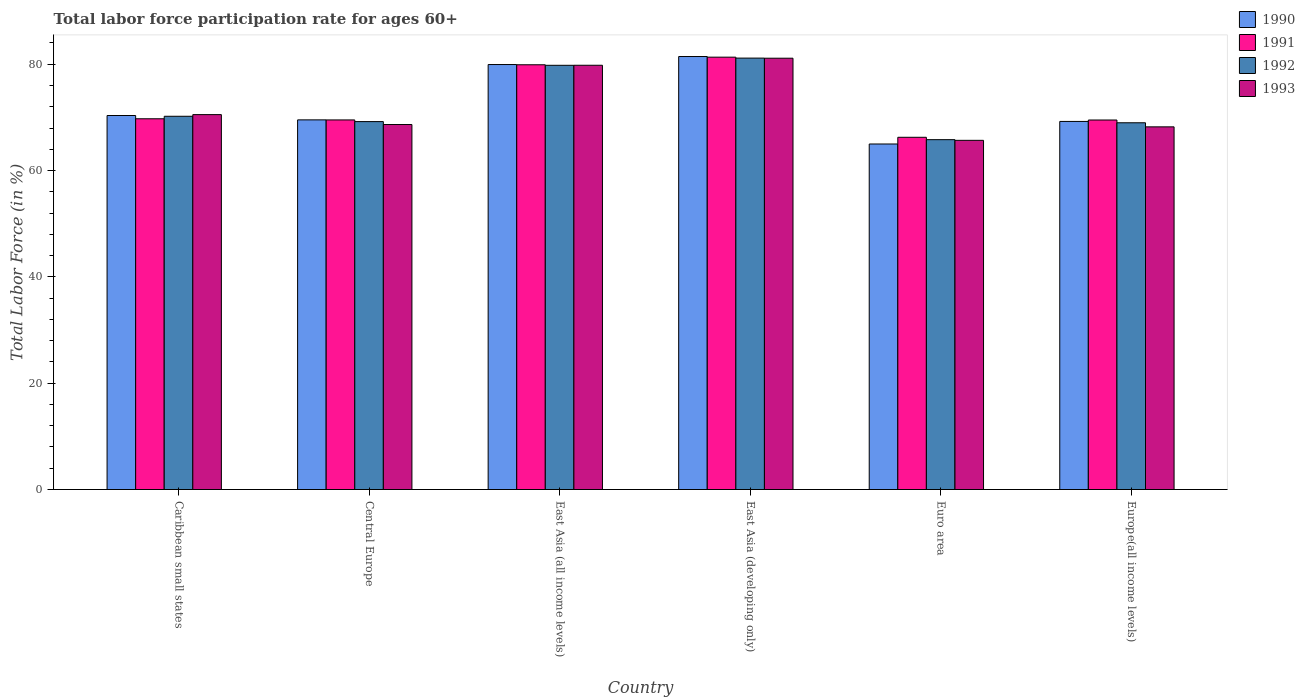Are the number of bars on each tick of the X-axis equal?
Offer a terse response. Yes. How many bars are there on the 6th tick from the left?
Provide a succinct answer. 4. How many bars are there on the 6th tick from the right?
Your response must be concise. 4. What is the label of the 1st group of bars from the left?
Offer a very short reply. Caribbean small states. In how many cases, is the number of bars for a given country not equal to the number of legend labels?
Your response must be concise. 0. What is the labor force participation rate in 1991 in East Asia (developing only)?
Give a very brief answer. 81.33. Across all countries, what is the maximum labor force participation rate in 1993?
Make the answer very short. 81.14. Across all countries, what is the minimum labor force participation rate in 1993?
Your response must be concise. 65.69. In which country was the labor force participation rate in 1990 maximum?
Your response must be concise. East Asia (developing only). In which country was the labor force participation rate in 1993 minimum?
Your answer should be compact. Euro area. What is the total labor force participation rate in 1990 in the graph?
Offer a very short reply. 435.54. What is the difference between the labor force participation rate in 1991 in East Asia (all income levels) and that in East Asia (developing only)?
Offer a very short reply. -1.43. What is the difference between the labor force participation rate in 1992 in Euro area and the labor force participation rate in 1990 in East Asia (developing only)?
Your answer should be compact. -15.64. What is the average labor force participation rate in 1991 per country?
Provide a short and direct response. 72.71. What is the difference between the labor force participation rate of/in 1990 and labor force participation rate of/in 1993 in East Asia (all income levels)?
Your answer should be compact. 0.14. In how many countries, is the labor force participation rate in 1993 greater than 72 %?
Your response must be concise. 2. What is the ratio of the labor force participation rate in 1992 in Caribbean small states to that in East Asia (developing only)?
Ensure brevity in your answer.  0.87. What is the difference between the highest and the second highest labor force participation rate in 1991?
Ensure brevity in your answer.  11.59. What is the difference between the highest and the lowest labor force participation rate in 1993?
Make the answer very short. 15.45. In how many countries, is the labor force participation rate in 1990 greater than the average labor force participation rate in 1990 taken over all countries?
Keep it short and to the point. 2. What does the 3rd bar from the right in Central Europe represents?
Give a very brief answer. 1991. Is it the case that in every country, the sum of the labor force participation rate in 1992 and labor force participation rate in 1990 is greater than the labor force participation rate in 1991?
Offer a very short reply. Yes. What is the difference between two consecutive major ticks on the Y-axis?
Offer a terse response. 20. Does the graph contain any zero values?
Provide a succinct answer. No. Does the graph contain grids?
Your answer should be very brief. No. How are the legend labels stacked?
Ensure brevity in your answer.  Vertical. What is the title of the graph?
Your response must be concise. Total labor force participation rate for ages 60+. Does "1972" appear as one of the legend labels in the graph?
Your answer should be compact. No. What is the label or title of the X-axis?
Provide a succinct answer. Country. What is the label or title of the Y-axis?
Your response must be concise. Total Labor Force (in %). What is the Total Labor Force (in %) in 1990 in Caribbean small states?
Your answer should be very brief. 70.36. What is the Total Labor Force (in %) in 1991 in Caribbean small states?
Provide a short and direct response. 69.74. What is the Total Labor Force (in %) in 1992 in Caribbean small states?
Offer a very short reply. 70.21. What is the Total Labor Force (in %) in 1993 in Caribbean small states?
Offer a terse response. 70.53. What is the Total Labor Force (in %) in 1990 in Central Europe?
Offer a terse response. 69.54. What is the Total Labor Force (in %) in 1991 in Central Europe?
Your response must be concise. 69.52. What is the Total Labor Force (in %) in 1992 in Central Europe?
Your answer should be compact. 69.21. What is the Total Labor Force (in %) of 1993 in Central Europe?
Give a very brief answer. 68.66. What is the Total Labor Force (in %) of 1990 in East Asia (all income levels)?
Provide a succinct answer. 79.95. What is the Total Labor Force (in %) of 1991 in East Asia (all income levels)?
Your answer should be compact. 79.9. What is the Total Labor Force (in %) of 1992 in East Asia (all income levels)?
Keep it short and to the point. 79.8. What is the Total Labor Force (in %) of 1993 in East Asia (all income levels)?
Your answer should be compact. 79.81. What is the Total Labor Force (in %) of 1990 in East Asia (developing only)?
Provide a succinct answer. 81.45. What is the Total Labor Force (in %) of 1991 in East Asia (developing only)?
Your answer should be compact. 81.33. What is the Total Labor Force (in %) of 1992 in East Asia (developing only)?
Make the answer very short. 81.16. What is the Total Labor Force (in %) in 1993 in East Asia (developing only)?
Keep it short and to the point. 81.14. What is the Total Labor Force (in %) in 1990 in Euro area?
Offer a terse response. 65. What is the Total Labor Force (in %) of 1991 in Euro area?
Your response must be concise. 66.26. What is the Total Labor Force (in %) in 1992 in Euro area?
Give a very brief answer. 65.81. What is the Total Labor Force (in %) in 1993 in Euro area?
Your answer should be compact. 65.69. What is the Total Labor Force (in %) of 1990 in Europe(all income levels)?
Keep it short and to the point. 69.24. What is the Total Labor Force (in %) of 1991 in Europe(all income levels)?
Give a very brief answer. 69.51. What is the Total Labor Force (in %) of 1992 in Europe(all income levels)?
Offer a terse response. 68.99. What is the Total Labor Force (in %) in 1993 in Europe(all income levels)?
Your answer should be compact. 68.22. Across all countries, what is the maximum Total Labor Force (in %) in 1990?
Keep it short and to the point. 81.45. Across all countries, what is the maximum Total Labor Force (in %) in 1991?
Give a very brief answer. 81.33. Across all countries, what is the maximum Total Labor Force (in %) in 1992?
Provide a succinct answer. 81.16. Across all countries, what is the maximum Total Labor Force (in %) of 1993?
Your answer should be compact. 81.14. Across all countries, what is the minimum Total Labor Force (in %) of 1990?
Provide a short and direct response. 65. Across all countries, what is the minimum Total Labor Force (in %) in 1991?
Offer a very short reply. 66.26. Across all countries, what is the minimum Total Labor Force (in %) of 1992?
Your answer should be compact. 65.81. Across all countries, what is the minimum Total Labor Force (in %) of 1993?
Provide a succinct answer. 65.69. What is the total Total Labor Force (in %) of 1990 in the graph?
Give a very brief answer. 435.54. What is the total Total Labor Force (in %) of 1991 in the graph?
Provide a short and direct response. 436.27. What is the total Total Labor Force (in %) of 1992 in the graph?
Provide a short and direct response. 435.19. What is the total Total Labor Force (in %) in 1993 in the graph?
Keep it short and to the point. 434.05. What is the difference between the Total Labor Force (in %) in 1990 in Caribbean small states and that in Central Europe?
Your answer should be compact. 0.82. What is the difference between the Total Labor Force (in %) in 1991 in Caribbean small states and that in Central Europe?
Your answer should be very brief. 0.22. What is the difference between the Total Labor Force (in %) of 1992 in Caribbean small states and that in Central Europe?
Provide a short and direct response. 1. What is the difference between the Total Labor Force (in %) of 1993 in Caribbean small states and that in Central Europe?
Provide a short and direct response. 1.86. What is the difference between the Total Labor Force (in %) of 1990 in Caribbean small states and that in East Asia (all income levels)?
Keep it short and to the point. -9.59. What is the difference between the Total Labor Force (in %) of 1991 in Caribbean small states and that in East Asia (all income levels)?
Offer a very short reply. -10.16. What is the difference between the Total Labor Force (in %) of 1992 in Caribbean small states and that in East Asia (all income levels)?
Give a very brief answer. -9.59. What is the difference between the Total Labor Force (in %) in 1993 in Caribbean small states and that in East Asia (all income levels)?
Make the answer very short. -9.28. What is the difference between the Total Labor Force (in %) of 1990 in Caribbean small states and that in East Asia (developing only)?
Your answer should be compact. -11.1. What is the difference between the Total Labor Force (in %) of 1991 in Caribbean small states and that in East Asia (developing only)?
Ensure brevity in your answer.  -11.59. What is the difference between the Total Labor Force (in %) in 1992 in Caribbean small states and that in East Asia (developing only)?
Provide a short and direct response. -10.94. What is the difference between the Total Labor Force (in %) in 1993 in Caribbean small states and that in East Asia (developing only)?
Keep it short and to the point. -10.61. What is the difference between the Total Labor Force (in %) of 1990 in Caribbean small states and that in Euro area?
Keep it short and to the point. 5.36. What is the difference between the Total Labor Force (in %) in 1991 in Caribbean small states and that in Euro area?
Provide a succinct answer. 3.48. What is the difference between the Total Labor Force (in %) of 1992 in Caribbean small states and that in Euro area?
Your answer should be very brief. 4.4. What is the difference between the Total Labor Force (in %) in 1993 in Caribbean small states and that in Euro area?
Make the answer very short. 4.84. What is the difference between the Total Labor Force (in %) in 1990 in Caribbean small states and that in Europe(all income levels)?
Ensure brevity in your answer.  1.11. What is the difference between the Total Labor Force (in %) in 1991 in Caribbean small states and that in Europe(all income levels)?
Offer a very short reply. 0.23. What is the difference between the Total Labor Force (in %) in 1992 in Caribbean small states and that in Europe(all income levels)?
Offer a very short reply. 1.22. What is the difference between the Total Labor Force (in %) of 1993 in Caribbean small states and that in Europe(all income levels)?
Offer a very short reply. 2.3. What is the difference between the Total Labor Force (in %) in 1990 in Central Europe and that in East Asia (all income levels)?
Ensure brevity in your answer.  -10.41. What is the difference between the Total Labor Force (in %) in 1991 in Central Europe and that in East Asia (all income levels)?
Make the answer very short. -10.38. What is the difference between the Total Labor Force (in %) of 1992 in Central Europe and that in East Asia (all income levels)?
Make the answer very short. -10.59. What is the difference between the Total Labor Force (in %) of 1993 in Central Europe and that in East Asia (all income levels)?
Make the answer very short. -11.15. What is the difference between the Total Labor Force (in %) in 1990 in Central Europe and that in East Asia (developing only)?
Your answer should be very brief. -11.92. What is the difference between the Total Labor Force (in %) in 1991 in Central Europe and that in East Asia (developing only)?
Offer a terse response. -11.81. What is the difference between the Total Labor Force (in %) in 1992 in Central Europe and that in East Asia (developing only)?
Your response must be concise. -11.95. What is the difference between the Total Labor Force (in %) in 1993 in Central Europe and that in East Asia (developing only)?
Make the answer very short. -12.48. What is the difference between the Total Labor Force (in %) of 1990 in Central Europe and that in Euro area?
Provide a short and direct response. 4.54. What is the difference between the Total Labor Force (in %) of 1991 in Central Europe and that in Euro area?
Provide a succinct answer. 3.27. What is the difference between the Total Labor Force (in %) in 1992 in Central Europe and that in Euro area?
Ensure brevity in your answer.  3.4. What is the difference between the Total Labor Force (in %) of 1993 in Central Europe and that in Euro area?
Offer a terse response. 2.98. What is the difference between the Total Labor Force (in %) of 1990 in Central Europe and that in Europe(all income levels)?
Keep it short and to the point. 0.29. What is the difference between the Total Labor Force (in %) of 1991 in Central Europe and that in Europe(all income levels)?
Your answer should be very brief. 0.01. What is the difference between the Total Labor Force (in %) of 1992 in Central Europe and that in Europe(all income levels)?
Provide a short and direct response. 0.22. What is the difference between the Total Labor Force (in %) of 1993 in Central Europe and that in Europe(all income levels)?
Offer a terse response. 0.44. What is the difference between the Total Labor Force (in %) of 1990 in East Asia (all income levels) and that in East Asia (developing only)?
Give a very brief answer. -1.51. What is the difference between the Total Labor Force (in %) of 1991 in East Asia (all income levels) and that in East Asia (developing only)?
Your answer should be compact. -1.43. What is the difference between the Total Labor Force (in %) in 1992 in East Asia (all income levels) and that in East Asia (developing only)?
Offer a terse response. -1.36. What is the difference between the Total Labor Force (in %) in 1993 in East Asia (all income levels) and that in East Asia (developing only)?
Offer a terse response. -1.33. What is the difference between the Total Labor Force (in %) of 1990 in East Asia (all income levels) and that in Euro area?
Your answer should be compact. 14.95. What is the difference between the Total Labor Force (in %) in 1991 in East Asia (all income levels) and that in Euro area?
Offer a terse response. 13.64. What is the difference between the Total Labor Force (in %) in 1992 in East Asia (all income levels) and that in Euro area?
Give a very brief answer. 13.99. What is the difference between the Total Labor Force (in %) of 1993 in East Asia (all income levels) and that in Euro area?
Your response must be concise. 14.12. What is the difference between the Total Labor Force (in %) in 1990 in East Asia (all income levels) and that in Europe(all income levels)?
Provide a short and direct response. 10.7. What is the difference between the Total Labor Force (in %) in 1991 in East Asia (all income levels) and that in Europe(all income levels)?
Your response must be concise. 10.39. What is the difference between the Total Labor Force (in %) of 1992 in East Asia (all income levels) and that in Europe(all income levels)?
Your answer should be compact. 10.81. What is the difference between the Total Labor Force (in %) of 1993 in East Asia (all income levels) and that in Europe(all income levels)?
Provide a succinct answer. 11.59. What is the difference between the Total Labor Force (in %) of 1990 in East Asia (developing only) and that in Euro area?
Make the answer very short. 16.45. What is the difference between the Total Labor Force (in %) in 1991 in East Asia (developing only) and that in Euro area?
Ensure brevity in your answer.  15.07. What is the difference between the Total Labor Force (in %) of 1992 in East Asia (developing only) and that in Euro area?
Your answer should be very brief. 15.34. What is the difference between the Total Labor Force (in %) of 1993 in East Asia (developing only) and that in Euro area?
Ensure brevity in your answer.  15.45. What is the difference between the Total Labor Force (in %) of 1990 in East Asia (developing only) and that in Europe(all income levels)?
Give a very brief answer. 12.21. What is the difference between the Total Labor Force (in %) in 1991 in East Asia (developing only) and that in Europe(all income levels)?
Provide a succinct answer. 11.82. What is the difference between the Total Labor Force (in %) in 1992 in East Asia (developing only) and that in Europe(all income levels)?
Keep it short and to the point. 12.17. What is the difference between the Total Labor Force (in %) in 1993 in East Asia (developing only) and that in Europe(all income levels)?
Offer a terse response. 12.91. What is the difference between the Total Labor Force (in %) in 1990 in Euro area and that in Europe(all income levels)?
Give a very brief answer. -4.24. What is the difference between the Total Labor Force (in %) of 1991 in Euro area and that in Europe(all income levels)?
Offer a terse response. -3.25. What is the difference between the Total Labor Force (in %) of 1992 in Euro area and that in Europe(all income levels)?
Your answer should be very brief. -3.18. What is the difference between the Total Labor Force (in %) of 1993 in Euro area and that in Europe(all income levels)?
Provide a succinct answer. -2.54. What is the difference between the Total Labor Force (in %) in 1990 in Caribbean small states and the Total Labor Force (in %) in 1991 in Central Europe?
Make the answer very short. 0.83. What is the difference between the Total Labor Force (in %) in 1990 in Caribbean small states and the Total Labor Force (in %) in 1992 in Central Europe?
Your answer should be very brief. 1.15. What is the difference between the Total Labor Force (in %) of 1990 in Caribbean small states and the Total Labor Force (in %) of 1993 in Central Europe?
Make the answer very short. 1.7. What is the difference between the Total Labor Force (in %) in 1991 in Caribbean small states and the Total Labor Force (in %) in 1992 in Central Europe?
Keep it short and to the point. 0.53. What is the difference between the Total Labor Force (in %) in 1991 in Caribbean small states and the Total Labor Force (in %) in 1993 in Central Europe?
Provide a short and direct response. 1.08. What is the difference between the Total Labor Force (in %) in 1992 in Caribbean small states and the Total Labor Force (in %) in 1993 in Central Europe?
Offer a terse response. 1.55. What is the difference between the Total Labor Force (in %) in 1990 in Caribbean small states and the Total Labor Force (in %) in 1991 in East Asia (all income levels)?
Offer a terse response. -9.54. What is the difference between the Total Labor Force (in %) of 1990 in Caribbean small states and the Total Labor Force (in %) of 1992 in East Asia (all income levels)?
Ensure brevity in your answer.  -9.44. What is the difference between the Total Labor Force (in %) of 1990 in Caribbean small states and the Total Labor Force (in %) of 1993 in East Asia (all income levels)?
Offer a terse response. -9.45. What is the difference between the Total Labor Force (in %) in 1991 in Caribbean small states and the Total Labor Force (in %) in 1992 in East Asia (all income levels)?
Offer a very short reply. -10.06. What is the difference between the Total Labor Force (in %) in 1991 in Caribbean small states and the Total Labor Force (in %) in 1993 in East Asia (all income levels)?
Ensure brevity in your answer.  -10.07. What is the difference between the Total Labor Force (in %) of 1992 in Caribbean small states and the Total Labor Force (in %) of 1993 in East Asia (all income levels)?
Keep it short and to the point. -9.6. What is the difference between the Total Labor Force (in %) of 1990 in Caribbean small states and the Total Labor Force (in %) of 1991 in East Asia (developing only)?
Make the answer very short. -10.97. What is the difference between the Total Labor Force (in %) in 1990 in Caribbean small states and the Total Labor Force (in %) in 1992 in East Asia (developing only)?
Give a very brief answer. -10.8. What is the difference between the Total Labor Force (in %) of 1990 in Caribbean small states and the Total Labor Force (in %) of 1993 in East Asia (developing only)?
Provide a succinct answer. -10.78. What is the difference between the Total Labor Force (in %) in 1991 in Caribbean small states and the Total Labor Force (in %) in 1992 in East Asia (developing only)?
Your answer should be very brief. -11.42. What is the difference between the Total Labor Force (in %) in 1991 in Caribbean small states and the Total Labor Force (in %) in 1993 in East Asia (developing only)?
Offer a very short reply. -11.4. What is the difference between the Total Labor Force (in %) in 1992 in Caribbean small states and the Total Labor Force (in %) in 1993 in East Asia (developing only)?
Your answer should be compact. -10.92. What is the difference between the Total Labor Force (in %) in 1990 in Caribbean small states and the Total Labor Force (in %) in 1991 in Euro area?
Ensure brevity in your answer.  4.1. What is the difference between the Total Labor Force (in %) in 1990 in Caribbean small states and the Total Labor Force (in %) in 1992 in Euro area?
Offer a very short reply. 4.55. What is the difference between the Total Labor Force (in %) in 1990 in Caribbean small states and the Total Labor Force (in %) in 1993 in Euro area?
Keep it short and to the point. 4.67. What is the difference between the Total Labor Force (in %) in 1991 in Caribbean small states and the Total Labor Force (in %) in 1992 in Euro area?
Your answer should be very brief. 3.93. What is the difference between the Total Labor Force (in %) of 1991 in Caribbean small states and the Total Labor Force (in %) of 1993 in Euro area?
Make the answer very short. 4.06. What is the difference between the Total Labor Force (in %) in 1992 in Caribbean small states and the Total Labor Force (in %) in 1993 in Euro area?
Your answer should be compact. 4.53. What is the difference between the Total Labor Force (in %) in 1990 in Caribbean small states and the Total Labor Force (in %) in 1991 in Europe(all income levels)?
Offer a very short reply. 0.85. What is the difference between the Total Labor Force (in %) of 1990 in Caribbean small states and the Total Labor Force (in %) of 1992 in Europe(all income levels)?
Your response must be concise. 1.37. What is the difference between the Total Labor Force (in %) in 1990 in Caribbean small states and the Total Labor Force (in %) in 1993 in Europe(all income levels)?
Keep it short and to the point. 2.13. What is the difference between the Total Labor Force (in %) of 1991 in Caribbean small states and the Total Labor Force (in %) of 1992 in Europe(all income levels)?
Ensure brevity in your answer.  0.75. What is the difference between the Total Labor Force (in %) in 1991 in Caribbean small states and the Total Labor Force (in %) in 1993 in Europe(all income levels)?
Give a very brief answer. 1.52. What is the difference between the Total Labor Force (in %) of 1992 in Caribbean small states and the Total Labor Force (in %) of 1993 in Europe(all income levels)?
Your answer should be compact. 1.99. What is the difference between the Total Labor Force (in %) of 1990 in Central Europe and the Total Labor Force (in %) of 1991 in East Asia (all income levels)?
Give a very brief answer. -10.37. What is the difference between the Total Labor Force (in %) in 1990 in Central Europe and the Total Labor Force (in %) in 1992 in East Asia (all income levels)?
Provide a succinct answer. -10.27. What is the difference between the Total Labor Force (in %) in 1990 in Central Europe and the Total Labor Force (in %) in 1993 in East Asia (all income levels)?
Give a very brief answer. -10.27. What is the difference between the Total Labor Force (in %) in 1991 in Central Europe and the Total Labor Force (in %) in 1992 in East Asia (all income levels)?
Offer a terse response. -10.28. What is the difference between the Total Labor Force (in %) in 1991 in Central Europe and the Total Labor Force (in %) in 1993 in East Asia (all income levels)?
Provide a succinct answer. -10.28. What is the difference between the Total Labor Force (in %) in 1992 in Central Europe and the Total Labor Force (in %) in 1993 in East Asia (all income levels)?
Make the answer very short. -10.6. What is the difference between the Total Labor Force (in %) in 1990 in Central Europe and the Total Labor Force (in %) in 1991 in East Asia (developing only)?
Keep it short and to the point. -11.8. What is the difference between the Total Labor Force (in %) in 1990 in Central Europe and the Total Labor Force (in %) in 1992 in East Asia (developing only)?
Provide a short and direct response. -11.62. What is the difference between the Total Labor Force (in %) in 1990 in Central Europe and the Total Labor Force (in %) in 1993 in East Asia (developing only)?
Give a very brief answer. -11.6. What is the difference between the Total Labor Force (in %) of 1991 in Central Europe and the Total Labor Force (in %) of 1992 in East Asia (developing only)?
Your answer should be compact. -11.63. What is the difference between the Total Labor Force (in %) of 1991 in Central Europe and the Total Labor Force (in %) of 1993 in East Asia (developing only)?
Offer a very short reply. -11.61. What is the difference between the Total Labor Force (in %) of 1992 in Central Europe and the Total Labor Force (in %) of 1993 in East Asia (developing only)?
Your answer should be very brief. -11.93. What is the difference between the Total Labor Force (in %) of 1990 in Central Europe and the Total Labor Force (in %) of 1991 in Euro area?
Offer a terse response. 3.28. What is the difference between the Total Labor Force (in %) of 1990 in Central Europe and the Total Labor Force (in %) of 1992 in Euro area?
Make the answer very short. 3.72. What is the difference between the Total Labor Force (in %) in 1990 in Central Europe and the Total Labor Force (in %) in 1993 in Euro area?
Your answer should be very brief. 3.85. What is the difference between the Total Labor Force (in %) of 1991 in Central Europe and the Total Labor Force (in %) of 1992 in Euro area?
Give a very brief answer. 3.71. What is the difference between the Total Labor Force (in %) of 1991 in Central Europe and the Total Labor Force (in %) of 1993 in Euro area?
Offer a terse response. 3.84. What is the difference between the Total Labor Force (in %) in 1992 in Central Europe and the Total Labor Force (in %) in 1993 in Euro area?
Your answer should be compact. 3.53. What is the difference between the Total Labor Force (in %) of 1990 in Central Europe and the Total Labor Force (in %) of 1991 in Europe(all income levels)?
Give a very brief answer. 0.02. What is the difference between the Total Labor Force (in %) of 1990 in Central Europe and the Total Labor Force (in %) of 1992 in Europe(all income levels)?
Your response must be concise. 0.54. What is the difference between the Total Labor Force (in %) of 1990 in Central Europe and the Total Labor Force (in %) of 1993 in Europe(all income levels)?
Keep it short and to the point. 1.31. What is the difference between the Total Labor Force (in %) of 1991 in Central Europe and the Total Labor Force (in %) of 1992 in Europe(all income levels)?
Keep it short and to the point. 0.53. What is the difference between the Total Labor Force (in %) in 1991 in Central Europe and the Total Labor Force (in %) in 1993 in Europe(all income levels)?
Offer a terse response. 1.3. What is the difference between the Total Labor Force (in %) of 1992 in Central Europe and the Total Labor Force (in %) of 1993 in Europe(all income levels)?
Your response must be concise. 0.99. What is the difference between the Total Labor Force (in %) in 1990 in East Asia (all income levels) and the Total Labor Force (in %) in 1991 in East Asia (developing only)?
Give a very brief answer. -1.39. What is the difference between the Total Labor Force (in %) of 1990 in East Asia (all income levels) and the Total Labor Force (in %) of 1992 in East Asia (developing only)?
Provide a short and direct response. -1.21. What is the difference between the Total Labor Force (in %) of 1990 in East Asia (all income levels) and the Total Labor Force (in %) of 1993 in East Asia (developing only)?
Ensure brevity in your answer.  -1.19. What is the difference between the Total Labor Force (in %) in 1991 in East Asia (all income levels) and the Total Labor Force (in %) in 1992 in East Asia (developing only)?
Give a very brief answer. -1.26. What is the difference between the Total Labor Force (in %) in 1991 in East Asia (all income levels) and the Total Labor Force (in %) in 1993 in East Asia (developing only)?
Ensure brevity in your answer.  -1.24. What is the difference between the Total Labor Force (in %) in 1992 in East Asia (all income levels) and the Total Labor Force (in %) in 1993 in East Asia (developing only)?
Make the answer very short. -1.34. What is the difference between the Total Labor Force (in %) of 1990 in East Asia (all income levels) and the Total Labor Force (in %) of 1991 in Euro area?
Keep it short and to the point. 13.69. What is the difference between the Total Labor Force (in %) of 1990 in East Asia (all income levels) and the Total Labor Force (in %) of 1992 in Euro area?
Your response must be concise. 14.13. What is the difference between the Total Labor Force (in %) in 1990 in East Asia (all income levels) and the Total Labor Force (in %) in 1993 in Euro area?
Offer a very short reply. 14.26. What is the difference between the Total Labor Force (in %) in 1991 in East Asia (all income levels) and the Total Labor Force (in %) in 1992 in Euro area?
Provide a short and direct response. 14.09. What is the difference between the Total Labor Force (in %) of 1991 in East Asia (all income levels) and the Total Labor Force (in %) of 1993 in Euro area?
Keep it short and to the point. 14.22. What is the difference between the Total Labor Force (in %) in 1992 in East Asia (all income levels) and the Total Labor Force (in %) in 1993 in Euro area?
Offer a terse response. 14.12. What is the difference between the Total Labor Force (in %) in 1990 in East Asia (all income levels) and the Total Labor Force (in %) in 1991 in Europe(all income levels)?
Provide a short and direct response. 10.43. What is the difference between the Total Labor Force (in %) in 1990 in East Asia (all income levels) and the Total Labor Force (in %) in 1992 in Europe(all income levels)?
Your answer should be very brief. 10.95. What is the difference between the Total Labor Force (in %) of 1990 in East Asia (all income levels) and the Total Labor Force (in %) of 1993 in Europe(all income levels)?
Make the answer very short. 11.72. What is the difference between the Total Labor Force (in %) in 1991 in East Asia (all income levels) and the Total Labor Force (in %) in 1992 in Europe(all income levels)?
Your answer should be very brief. 10.91. What is the difference between the Total Labor Force (in %) of 1991 in East Asia (all income levels) and the Total Labor Force (in %) of 1993 in Europe(all income levels)?
Keep it short and to the point. 11.68. What is the difference between the Total Labor Force (in %) in 1992 in East Asia (all income levels) and the Total Labor Force (in %) in 1993 in Europe(all income levels)?
Provide a short and direct response. 11.58. What is the difference between the Total Labor Force (in %) of 1990 in East Asia (developing only) and the Total Labor Force (in %) of 1991 in Euro area?
Keep it short and to the point. 15.19. What is the difference between the Total Labor Force (in %) in 1990 in East Asia (developing only) and the Total Labor Force (in %) in 1992 in Euro area?
Give a very brief answer. 15.64. What is the difference between the Total Labor Force (in %) in 1990 in East Asia (developing only) and the Total Labor Force (in %) in 1993 in Euro area?
Provide a short and direct response. 15.77. What is the difference between the Total Labor Force (in %) of 1991 in East Asia (developing only) and the Total Labor Force (in %) of 1992 in Euro area?
Give a very brief answer. 15.52. What is the difference between the Total Labor Force (in %) in 1991 in East Asia (developing only) and the Total Labor Force (in %) in 1993 in Euro area?
Your answer should be very brief. 15.65. What is the difference between the Total Labor Force (in %) in 1992 in East Asia (developing only) and the Total Labor Force (in %) in 1993 in Euro area?
Offer a very short reply. 15.47. What is the difference between the Total Labor Force (in %) in 1990 in East Asia (developing only) and the Total Labor Force (in %) in 1991 in Europe(all income levels)?
Provide a succinct answer. 11.94. What is the difference between the Total Labor Force (in %) of 1990 in East Asia (developing only) and the Total Labor Force (in %) of 1992 in Europe(all income levels)?
Offer a very short reply. 12.46. What is the difference between the Total Labor Force (in %) of 1990 in East Asia (developing only) and the Total Labor Force (in %) of 1993 in Europe(all income levels)?
Your answer should be very brief. 13.23. What is the difference between the Total Labor Force (in %) in 1991 in East Asia (developing only) and the Total Labor Force (in %) in 1992 in Europe(all income levels)?
Your answer should be compact. 12.34. What is the difference between the Total Labor Force (in %) of 1991 in East Asia (developing only) and the Total Labor Force (in %) of 1993 in Europe(all income levels)?
Your answer should be compact. 13.11. What is the difference between the Total Labor Force (in %) in 1992 in East Asia (developing only) and the Total Labor Force (in %) in 1993 in Europe(all income levels)?
Give a very brief answer. 12.93. What is the difference between the Total Labor Force (in %) in 1990 in Euro area and the Total Labor Force (in %) in 1991 in Europe(all income levels)?
Ensure brevity in your answer.  -4.51. What is the difference between the Total Labor Force (in %) of 1990 in Euro area and the Total Labor Force (in %) of 1992 in Europe(all income levels)?
Your response must be concise. -3.99. What is the difference between the Total Labor Force (in %) of 1990 in Euro area and the Total Labor Force (in %) of 1993 in Europe(all income levels)?
Your answer should be very brief. -3.22. What is the difference between the Total Labor Force (in %) of 1991 in Euro area and the Total Labor Force (in %) of 1992 in Europe(all income levels)?
Your response must be concise. -2.73. What is the difference between the Total Labor Force (in %) in 1991 in Euro area and the Total Labor Force (in %) in 1993 in Europe(all income levels)?
Provide a short and direct response. -1.97. What is the difference between the Total Labor Force (in %) of 1992 in Euro area and the Total Labor Force (in %) of 1993 in Europe(all income levels)?
Your answer should be compact. -2.41. What is the average Total Labor Force (in %) of 1990 per country?
Give a very brief answer. 72.59. What is the average Total Labor Force (in %) of 1991 per country?
Make the answer very short. 72.71. What is the average Total Labor Force (in %) in 1992 per country?
Provide a succinct answer. 72.53. What is the average Total Labor Force (in %) of 1993 per country?
Offer a terse response. 72.34. What is the difference between the Total Labor Force (in %) in 1990 and Total Labor Force (in %) in 1991 in Caribbean small states?
Your answer should be compact. 0.62. What is the difference between the Total Labor Force (in %) in 1990 and Total Labor Force (in %) in 1992 in Caribbean small states?
Offer a very short reply. 0.14. What is the difference between the Total Labor Force (in %) of 1990 and Total Labor Force (in %) of 1993 in Caribbean small states?
Give a very brief answer. -0.17. What is the difference between the Total Labor Force (in %) of 1991 and Total Labor Force (in %) of 1992 in Caribbean small states?
Provide a succinct answer. -0.47. What is the difference between the Total Labor Force (in %) in 1991 and Total Labor Force (in %) in 1993 in Caribbean small states?
Offer a terse response. -0.78. What is the difference between the Total Labor Force (in %) of 1992 and Total Labor Force (in %) of 1993 in Caribbean small states?
Your answer should be compact. -0.31. What is the difference between the Total Labor Force (in %) in 1990 and Total Labor Force (in %) in 1991 in Central Europe?
Keep it short and to the point. 0.01. What is the difference between the Total Labor Force (in %) in 1990 and Total Labor Force (in %) in 1992 in Central Europe?
Give a very brief answer. 0.32. What is the difference between the Total Labor Force (in %) in 1990 and Total Labor Force (in %) in 1993 in Central Europe?
Provide a short and direct response. 0.87. What is the difference between the Total Labor Force (in %) in 1991 and Total Labor Force (in %) in 1992 in Central Europe?
Provide a succinct answer. 0.31. What is the difference between the Total Labor Force (in %) in 1991 and Total Labor Force (in %) in 1993 in Central Europe?
Make the answer very short. 0.86. What is the difference between the Total Labor Force (in %) of 1992 and Total Labor Force (in %) of 1993 in Central Europe?
Provide a short and direct response. 0.55. What is the difference between the Total Labor Force (in %) in 1990 and Total Labor Force (in %) in 1991 in East Asia (all income levels)?
Keep it short and to the point. 0.04. What is the difference between the Total Labor Force (in %) in 1990 and Total Labor Force (in %) in 1992 in East Asia (all income levels)?
Your answer should be compact. 0.14. What is the difference between the Total Labor Force (in %) in 1990 and Total Labor Force (in %) in 1993 in East Asia (all income levels)?
Offer a terse response. 0.14. What is the difference between the Total Labor Force (in %) of 1991 and Total Labor Force (in %) of 1992 in East Asia (all income levels)?
Keep it short and to the point. 0.1. What is the difference between the Total Labor Force (in %) of 1991 and Total Labor Force (in %) of 1993 in East Asia (all income levels)?
Provide a succinct answer. 0.09. What is the difference between the Total Labor Force (in %) in 1992 and Total Labor Force (in %) in 1993 in East Asia (all income levels)?
Ensure brevity in your answer.  -0.01. What is the difference between the Total Labor Force (in %) in 1990 and Total Labor Force (in %) in 1991 in East Asia (developing only)?
Give a very brief answer. 0.12. What is the difference between the Total Labor Force (in %) in 1990 and Total Labor Force (in %) in 1992 in East Asia (developing only)?
Your answer should be very brief. 0.3. What is the difference between the Total Labor Force (in %) of 1990 and Total Labor Force (in %) of 1993 in East Asia (developing only)?
Ensure brevity in your answer.  0.32. What is the difference between the Total Labor Force (in %) of 1991 and Total Labor Force (in %) of 1992 in East Asia (developing only)?
Make the answer very short. 0.17. What is the difference between the Total Labor Force (in %) in 1991 and Total Labor Force (in %) in 1993 in East Asia (developing only)?
Give a very brief answer. 0.19. What is the difference between the Total Labor Force (in %) of 1992 and Total Labor Force (in %) of 1993 in East Asia (developing only)?
Provide a short and direct response. 0.02. What is the difference between the Total Labor Force (in %) in 1990 and Total Labor Force (in %) in 1991 in Euro area?
Make the answer very short. -1.26. What is the difference between the Total Labor Force (in %) in 1990 and Total Labor Force (in %) in 1992 in Euro area?
Your answer should be very brief. -0.81. What is the difference between the Total Labor Force (in %) of 1990 and Total Labor Force (in %) of 1993 in Euro area?
Make the answer very short. -0.69. What is the difference between the Total Labor Force (in %) of 1991 and Total Labor Force (in %) of 1992 in Euro area?
Give a very brief answer. 0.45. What is the difference between the Total Labor Force (in %) in 1991 and Total Labor Force (in %) in 1993 in Euro area?
Provide a short and direct response. 0.57. What is the difference between the Total Labor Force (in %) in 1992 and Total Labor Force (in %) in 1993 in Euro area?
Make the answer very short. 0.13. What is the difference between the Total Labor Force (in %) of 1990 and Total Labor Force (in %) of 1991 in Europe(all income levels)?
Offer a terse response. -0.27. What is the difference between the Total Labor Force (in %) of 1990 and Total Labor Force (in %) of 1992 in Europe(all income levels)?
Provide a succinct answer. 0.25. What is the difference between the Total Labor Force (in %) in 1990 and Total Labor Force (in %) in 1993 in Europe(all income levels)?
Offer a very short reply. 1.02. What is the difference between the Total Labor Force (in %) of 1991 and Total Labor Force (in %) of 1992 in Europe(all income levels)?
Ensure brevity in your answer.  0.52. What is the difference between the Total Labor Force (in %) of 1991 and Total Labor Force (in %) of 1993 in Europe(all income levels)?
Your response must be concise. 1.29. What is the difference between the Total Labor Force (in %) of 1992 and Total Labor Force (in %) of 1993 in Europe(all income levels)?
Provide a short and direct response. 0.77. What is the ratio of the Total Labor Force (in %) in 1990 in Caribbean small states to that in Central Europe?
Make the answer very short. 1.01. What is the ratio of the Total Labor Force (in %) of 1992 in Caribbean small states to that in Central Europe?
Provide a succinct answer. 1.01. What is the ratio of the Total Labor Force (in %) of 1993 in Caribbean small states to that in Central Europe?
Keep it short and to the point. 1.03. What is the ratio of the Total Labor Force (in %) of 1990 in Caribbean small states to that in East Asia (all income levels)?
Your answer should be compact. 0.88. What is the ratio of the Total Labor Force (in %) in 1991 in Caribbean small states to that in East Asia (all income levels)?
Give a very brief answer. 0.87. What is the ratio of the Total Labor Force (in %) of 1992 in Caribbean small states to that in East Asia (all income levels)?
Give a very brief answer. 0.88. What is the ratio of the Total Labor Force (in %) of 1993 in Caribbean small states to that in East Asia (all income levels)?
Offer a terse response. 0.88. What is the ratio of the Total Labor Force (in %) of 1990 in Caribbean small states to that in East Asia (developing only)?
Your answer should be compact. 0.86. What is the ratio of the Total Labor Force (in %) in 1991 in Caribbean small states to that in East Asia (developing only)?
Give a very brief answer. 0.86. What is the ratio of the Total Labor Force (in %) in 1992 in Caribbean small states to that in East Asia (developing only)?
Ensure brevity in your answer.  0.87. What is the ratio of the Total Labor Force (in %) of 1993 in Caribbean small states to that in East Asia (developing only)?
Give a very brief answer. 0.87. What is the ratio of the Total Labor Force (in %) of 1990 in Caribbean small states to that in Euro area?
Offer a terse response. 1.08. What is the ratio of the Total Labor Force (in %) of 1991 in Caribbean small states to that in Euro area?
Offer a very short reply. 1.05. What is the ratio of the Total Labor Force (in %) of 1992 in Caribbean small states to that in Euro area?
Your answer should be compact. 1.07. What is the ratio of the Total Labor Force (in %) of 1993 in Caribbean small states to that in Euro area?
Offer a terse response. 1.07. What is the ratio of the Total Labor Force (in %) in 1990 in Caribbean small states to that in Europe(all income levels)?
Keep it short and to the point. 1.02. What is the ratio of the Total Labor Force (in %) of 1991 in Caribbean small states to that in Europe(all income levels)?
Your answer should be compact. 1. What is the ratio of the Total Labor Force (in %) of 1992 in Caribbean small states to that in Europe(all income levels)?
Offer a terse response. 1.02. What is the ratio of the Total Labor Force (in %) in 1993 in Caribbean small states to that in Europe(all income levels)?
Keep it short and to the point. 1.03. What is the ratio of the Total Labor Force (in %) of 1990 in Central Europe to that in East Asia (all income levels)?
Provide a short and direct response. 0.87. What is the ratio of the Total Labor Force (in %) in 1991 in Central Europe to that in East Asia (all income levels)?
Provide a short and direct response. 0.87. What is the ratio of the Total Labor Force (in %) of 1992 in Central Europe to that in East Asia (all income levels)?
Your answer should be compact. 0.87. What is the ratio of the Total Labor Force (in %) in 1993 in Central Europe to that in East Asia (all income levels)?
Offer a very short reply. 0.86. What is the ratio of the Total Labor Force (in %) in 1990 in Central Europe to that in East Asia (developing only)?
Offer a terse response. 0.85. What is the ratio of the Total Labor Force (in %) in 1991 in Central Europe to that in East Asia (developing only)?
Ensure brevity in your answer.  0.85. What is the ratio of the Total Labor Force (in %) of 1992 in Central Europe to that in East Asia (developing only)?
Keep it short and to the point. 0.85. What is the ratio of the Total Labor Force (in %) of 1993 in Central Europe to that in East Asia (developing only)?
Ensure brevity in your answer.  0.85. What is the ratio of the Total Labor Force (in %) in 1990 in Central Europe to that in Euro area?
Make the answer very short. 1.07. What is the ratio of the Total Labor Force (in %) of 1991 in Central Europe to that in Euro area?
Make the answer very short. 1.05. What is the ratio of the Total Labor Force (in %) of 1992 in Central Europe to that in Euro area?
Your answer should be compact. 1.05. What is the ratio of the Total Labor Force (in %) in 1993 in Central Europe to that in Euro area?
Your answer should be compact. 1.05. What is the ratio of the Total Labor Force (in %) of 1990 in Central Europe to that in Europe(all income levels)?
Offer a very short reply. 1. What is the ratio of the Total Labor Force (in %) in 1992 in Central Europe to that in Europe(all income levels)?
Provide a succinct answer. 1. What is the ratio of the Total Labor Force (in %) in 1993 in Central Europe to that in Europe(all income levels)?
Provide a succinct answer. 1.01. What is the ratio of the Total Labor Force (in %) in 1990 in East Asia (all income levels) to that in East Asia (developing only)?
Your answer should be very brief. 0.98. What is the ratio of the Total Labor Force (in %) of 1991 in East Asia (all income levels) to that in East Asia (developing only)?
Offer a very short reply. 0.98. What is the ratio of the Total Labor Force (in %) in 1992 in East Asia (all income levels) to that in East Asia (developing only)?
Provide a succinct answer. 0.98. What is the ratio of the Total Labor Force (in %) of 1993 in East Asia (all income levels) to that in East Asia (developing only)?
Give a very brief answer. 0.98. What is the ratio of the Total Labor Force (in %) in 1990 in East Asia (all income levels) to that in Euro area?
Keep it short and to the point. 1.23. What is the ratio of the Total Labor Force (in %) in 1991 in East Asia (all income levels) to that in Euro area?
Keep it short and to the point. 1.21. What is the ratio of the Total Labor Force (in %) in 1992 in East Asia (all income levels) to that in Euro area?
Provide a short and direct response. 1.21. What is the ratio of the Total Labor Force (in %) of 1993 in East Asia (all income levels) to that in Euro area?
Offer a very short reply. 1.22. What is the ratio of the Total Labor Force (in %) of 1990 in East Asia (all income levels) to that in Europe(all income levels)?
Provide a short and direct response. 1.15. What is the ratio of the Total Labor Force (in %) of 1991 in East Asia (all income levels) to that in Europe(all income levels)?
Make the answer very short. 1.15. What is the ratio of the Total Labor Force (in %) in 1992 in East Asia (all income levels) to that in Europe(all income levels)?
Your response must be concise. 1.16. What is the ratio of the Total Labor Force (in %) in 1993 in East Asia (all income levels) to that in Europe(all income levels)?
Your answer should be compact. 1.17. What is the ratio of the Total Labor Force (in %) of 1990 in East Asia (developing only) to that in Euro area?
Keep it short and to the point. 1.25. What is the ratio of the Total Labor Force (in %) in 1991 in East Asia (developing only) to that in Euro area?
Give a very brief answer. 1.23. What is the ratio of the Total Labor Force (in %) of 1992 in East Asia (developing only) to that in Euro area?
Your answer should be compact. 1.23. What is the ratio of the Total Labor Force (in %) of 1993 in East Asia (developing only) to that in Euro area?
Provide a short and direct response. 1.24. What is the ratio of the Total Labor Force (in %) of 1990 in East Asia (developing only) to that in Europe(all income levels)?
Your answer should be very brief. 1.18. What is the ratio of the Total Labor Force (in %) in 1991 in East Asia (developing only) to that in Europe(all income levels)?
Your answer should be compact. 1.17. What is the ratio of the Total Labor Force (in %) of 1992 in East Asia (developing only) to that in Europe(all income levels)?
Make the answer very short. 1.18. What is the ratio of the Total Labor Force (in %) of 1993 in East Asia (developing only) to that in Europe(all income levels)?
Give a very brief answer. 1.19. What is the ratio of the Total Labor Force (in %) of 1990 in Euro area to that in Europe(all income levels)?
Give a very brief answer. 0.94. What is the ratio of the Total Labor Force (in %) of 1991 in Euro area to that in Europe(all income levels)?
Your answer should be very brief. 0.95. What is the ratio of the Total Labor Force (in %) in 1992 in Euro area to that in Europe(all income levels)?
Your response must be concise. 0.95. What is the ratio of the Total Labor Force (in %) of 1993 in Euro area to that in Europe(all income levels)?
Make the answer very short. 0.96. What is the difference between the highest and the second highest Total Labor Force (in %) in 1990?
Ensure brevity in your answer.  1.51. What is the difference between the highest and the second highest Total Labor Force (in %) in 1991?
Offer a terse response. 1.43. What is the difference between the highest and the second highest Total Labor Force (in %) of 1992?
Provide a short and direct response. 1.36. What is the difference between the highest and the second highest Total Labor Force (in %) in 1993?
Provide a short and direct response. 1.33. What is the difference between the highest and the lowest Total Labor Force (in %) in 1990?
Offer a terse response. 16.45. What is the difference between the highest and the lowest Total Labor Force (in %) in 1991?
Your response must be concise. 15.07. What is the difference between the highest and the lowest Total Labor Force (in %) of 1992?
Your answer should be very brief. 15.34. What is the difference between the highest and the lowest Total Labor Force (in %) in 1993?
Your answer should be very brief. 15.45. 